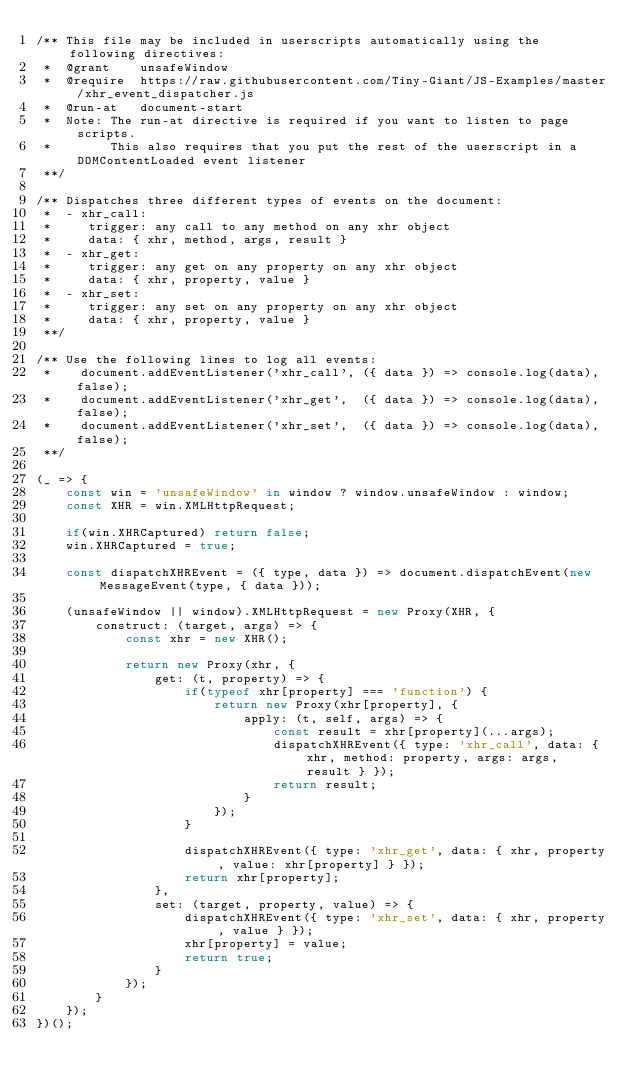Convert code to text. <code><loc_0><loc_0><loc_500><loc_500><_JavaScript_>/** This file may be included in userscripts automatically using the following directives:
 *  @grant    unsafeWindow
 *  @require  https://raw.githubusercontent.com/Tiny-Giant/JS-Examples/master/xhr_event_dispatcher.js
 *  @run-at   document-start
 *  Note: The run-at directive is required if you want to listen to page scripts.
 *        This also requires that you put the rest of the userscript in a DOMContentLoaded event listener
 **/

/** Dispatches three different types of events on the document:
 *  - xhr_call:
 *     trigger: any call to any method on any xhr object
 *     data: { xhr, method, args, result }
 *  - xhr_get:
 *     trigger: any get on any property on any xhr object
 *     data: { xhr, property, value }
 *  - xhr_set:
 *     trigger: any set on any property on any xhr object
 *     data: { xhr, property, value }
 **/

/** Use the following lines to log all events:
 *    document.addEventListener('xhr_call', ({ data }) => console.log(data), false);
 *    document.addEventListener('xhr_get',  ({ data }) => console.log(data), false);
 *    document.addEventListener('xhr_set',  ({ data }) => console.log(data), false);
 **/
 
(_ => {
    const win = 'unsafeWindow' in window ? window.unsafeWindow : window;
    const XHR = win.XMLHttpRequest;
 
    if(win.XHRCaptured) return false;
    win.XHRCaptured = true;   

    const dispatchXHREvent = ({ type, data }) => document.dispatchEvent(new MessageEvent(type, { data }));

    (unsafeWindow || window).XMLHttpRequest = new Proxy(XHR, {
        construct: (target, args) => {
            const xhr = new XHR();

            return new Proxy(xhr, {
                get: (t, property) => {
                    if(typeof xhr[property] === 'function') {
                        return new Proxy(xhr[property], {
                            apply: (t, self, args) => {
                                const result = xhr[property](...args);
                                dispatchXHREvent({ type: 'xhr_call', data: { xhr, method: property, args: args, result } });
                                return result;
                            }
                        });
                    }

                    dispatchXHREvent({ type: 'xhr_get', data: { xhr, property, value: xhr[property] } });
                    return xhr[property];
                },
                set: (target, property, value) => {
                    dispatchXHREvent({ type: 'xhr_set', data: { xhr, property, value } });
                    xhr[property] = value;
                    return true;
                }
            });
        }
    });
})();
</code> 